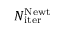<formula> <loc_0><loc_0><loc_500><loc_500>N _ { i t e r } ^ { N e w t }</formula> 